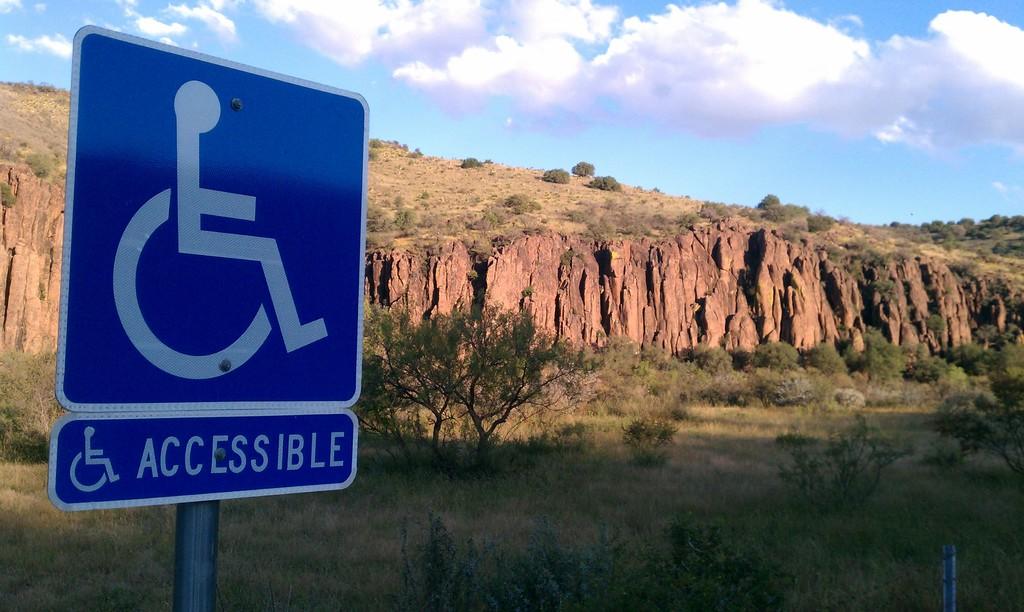Can a wheelchair be used in the area?
Ensure brevity in your answer.  Yes. What does the sign read under the handicapped symbol?
Provide a succinct answer. Accessible. 